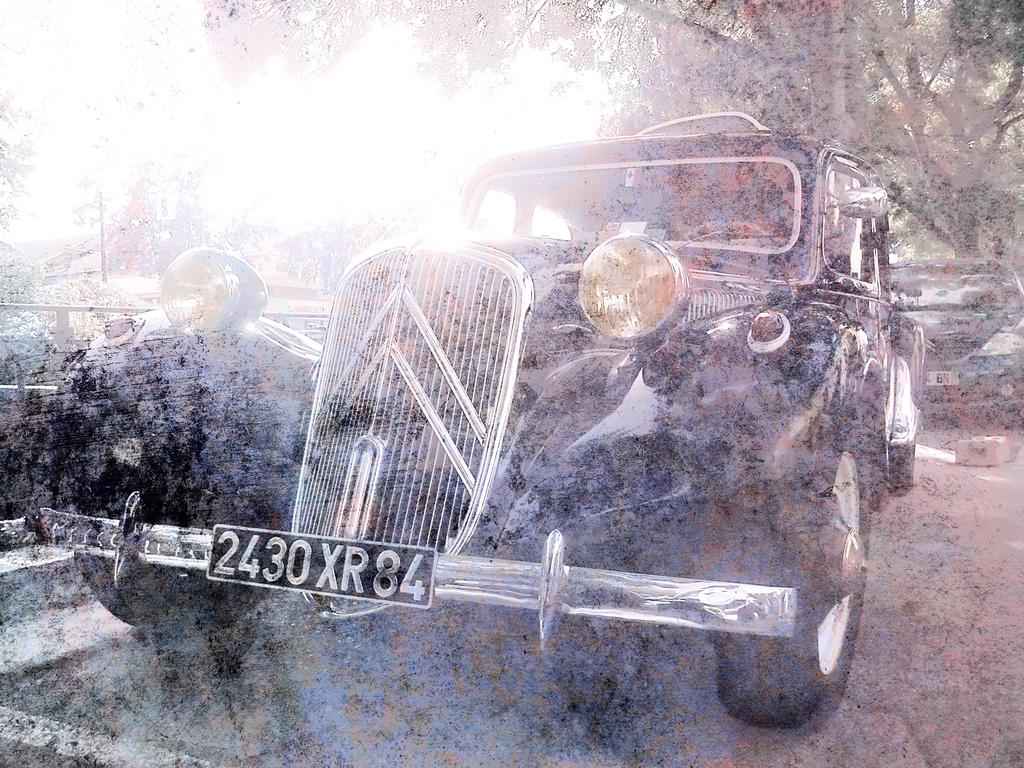What can be seen in the image related to transportation? There are cars parked in the image. Can you describe the car that is closest to the viewer? There is a black car in the front of the image. What type of natural element is visible in the background of the image? There is a tree visible in the background of the image. What page of the book does the tin shock in the image? There is no book, tin, or shock present in the image. 